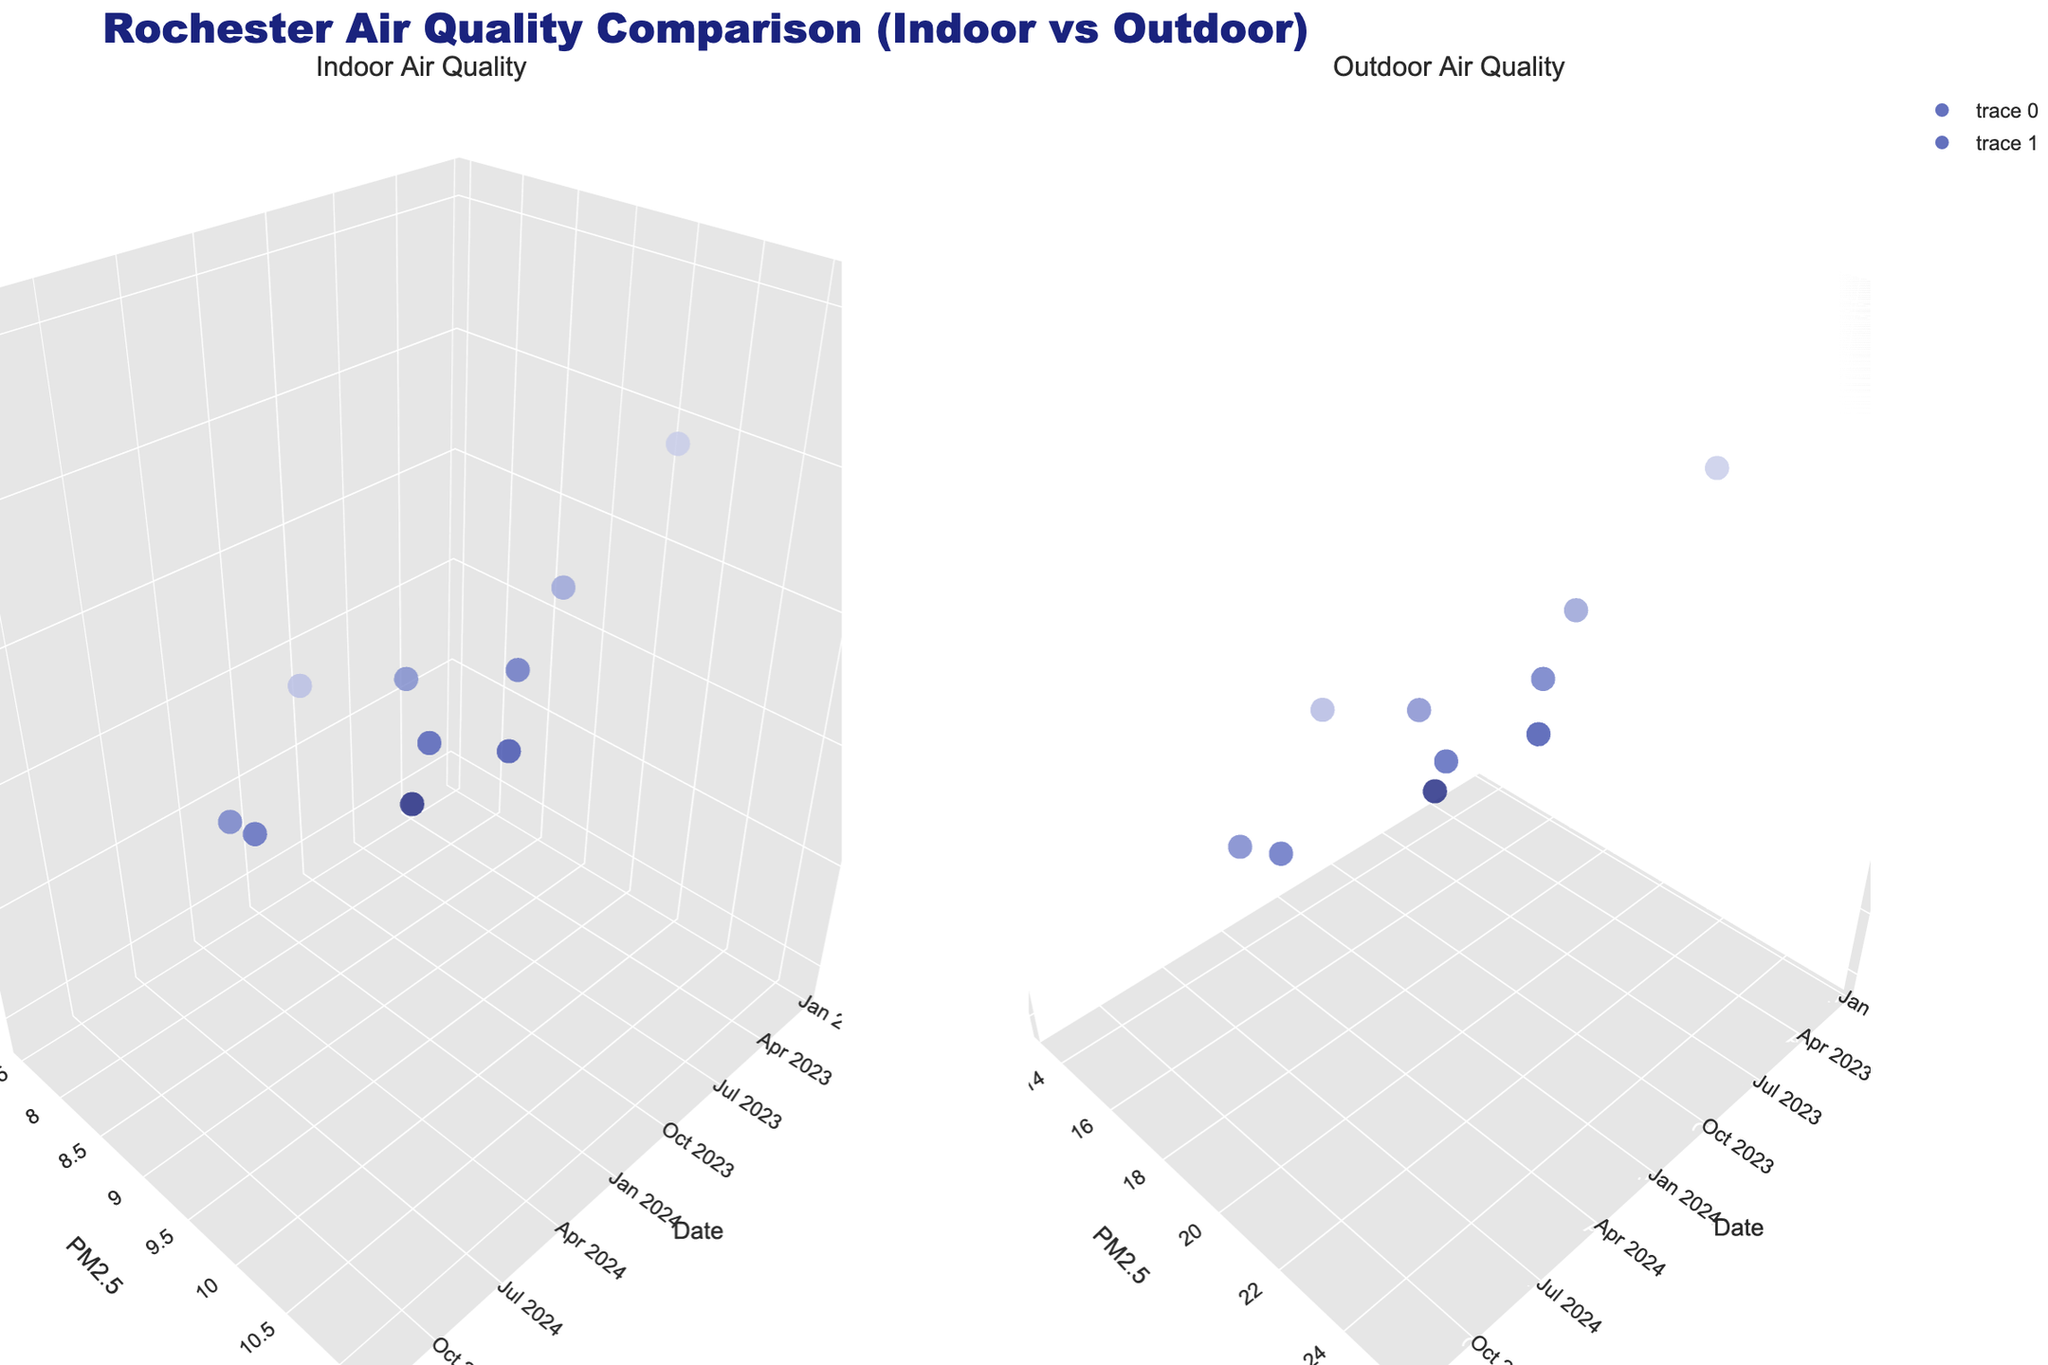What's the title of the plot? The title is located at the top of the plot. It reads "Rochester Air Quality Comparison (Indoor vs Outdoor)". The text is styled with a specific font and size.
Answer: Rochester Air Quality Comparison (Indoor vs Outdoor) Which subplot shows the outdoor air quality? There are two subplots in the figure, each representing different data aspects. The plot labeled "Outdoor Air Quality" is the one that depicts outdoor measurements.
Answer: The right subplot What is the maximum AQI value for indoor air quality? To find this, look at the color scale on the first subplot ("Indoor Air Quality") and identify the marker with the highest AQI.
Answer: 45 What's the PM2.5 level for outdoor air quality on 2024-03-22? Locate the date 2024-03-22 on the x-axis of the right subplot, then trace vertically to the corresponding PM2.5 level.
Answer: 20.4 How does the indoor PM10 trend over time appear compared to the outdoor PM10 trend? Observe the patterns in the height of the markers over time in both subplots. The indoor PM10 values show moderate variation, while outdoor PM10 tends to increase more significantly over time.
Answer: Indoor PM10 is relatively stable, while outdoor PM10 increases Which has higher PM2.5 levels on average, indoor or outdoor air? Observe the general elevation of markers on both subplots. Calculate the average PM2.5 values for both indoor and outdoor data points.
Answer: Outdoor air Is there a noticeable difference in AQI levels between indoor and outdoor air during winter months (December, January)? Compare AQI marker colors in both subplots for dates in December and January. Look for patterns indicating higher values.
Answer: Outdoor AQI is noticeably higher in winter months What is the indoor air quality (AQI) on September 1, 2023? Locate the date September 1, 2023, in the first subplot and identify the corresponding AQI through marker color or hover text.
Answer: 36 